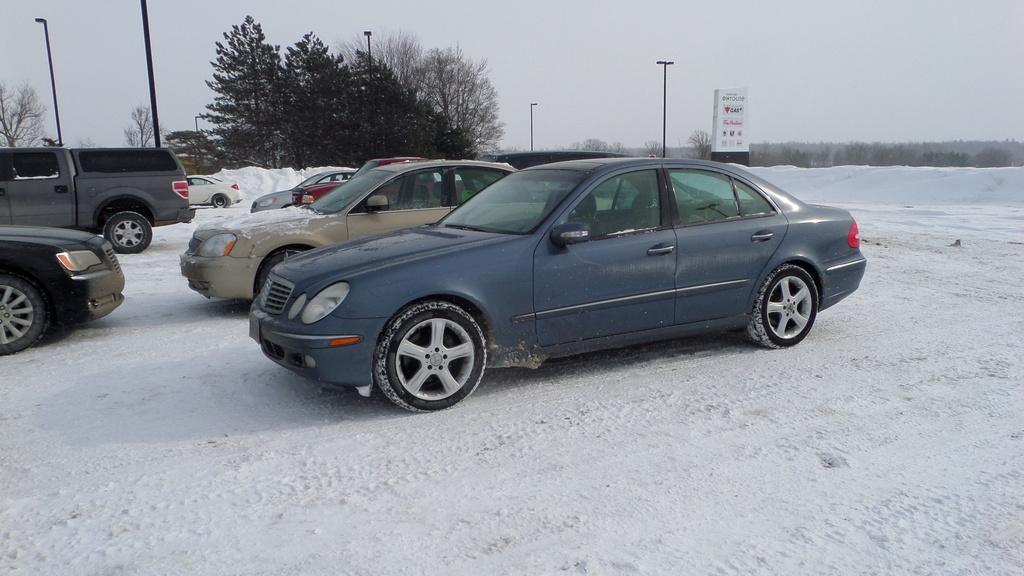How would you summarize this image in a sentence or two? In this image I can see the vehicles which are in different color. These are on the snow. In the background I can see the poles, many trees, boards and the sky. 